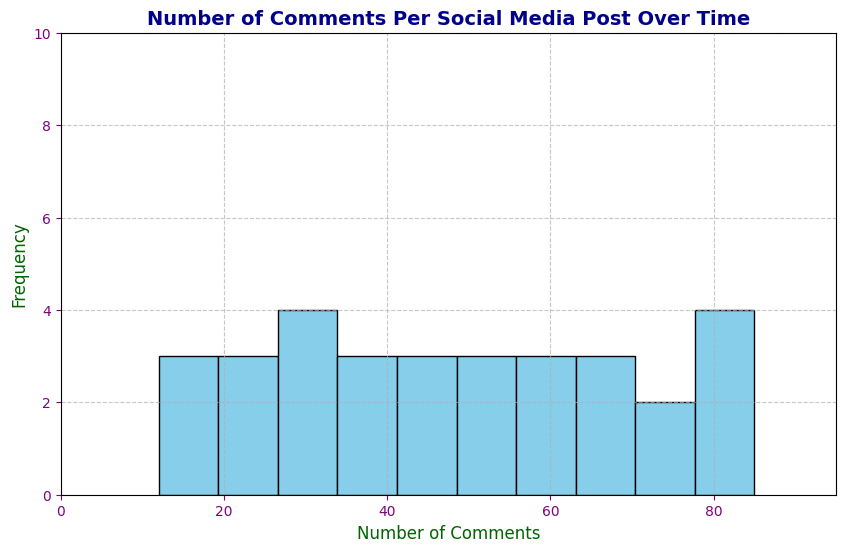what's the number of bins in the histogram? By observing the histogram, you can count the number of distinct bars (bins) present. There are 10 bars visible on the plot.
Answer: 10 what is the range of the x-axis on the histogram? The range of the x-axis can be determined by looking at the first and last values on that axis. The x-axis ranges from 0 to 95.
Answer: 0 to 95 how many comments fall in the range of 40-50? Look at the bin representing the range of 40-50 on the histogram and count the height of the bar. The bar for 40-50 has a frequency of 4.
Answer: 4 which range of comments has the highest frequency? Identify the tallest bar on the histogram and note its range on the x-axis. The range with the highest frequency is 70-80.
Answer: 70-80 is the frequency of comments in the range 60-70 greater than that in 50-60? Compare the heights of the bins for the ranges 60-70 and 50-60 on the histogram. The frequency for 60-70 (3) is greater than that for 50-60 (2).
Answer: Yes (3 vs 2) what's the frequency of comments in the range 10-20? Locate the bin for the range 10-20 on the histogram and read off its height. The frequency for the 10-20 range is 2.
Answer: 2 are there more comments in the range 30-40 or 20-30? Compare the heights of the bins for the ranges 30-40 and 20-30. The bin for 30-40 (2) is taller than that for 20-30 (1).
Answer: More in 30-40 (2 vs 1) what color are the bars in the histogram? Identify the color fill of the bars used in the histogram. The bars are sky blue.
Answer: sky blue 